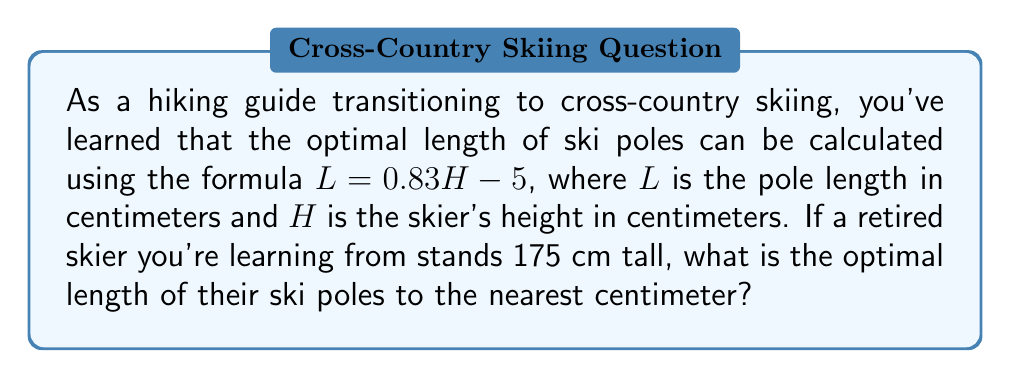Can you solve this math problem? To solve this problem, we'll follow these steps:

1. Identify the given information:
   - Formula: $L = 0.83H - 5$
   - Skier's height (H): 175 cm

2. Substitute the skier's height into the formula:
   $L = 0.83 \times 175 - 5$

3. Calculate the result:
   $L = 145.25 - 5$
   $L = 140.25$ cm

4. Round the result to the nearest centimeter:
   140.25 cm rounds to 140 cm

Therefore, the optimal length of ski poles for a skier who is 175 cm tall is 140 cm.
Answer: 140 cm 